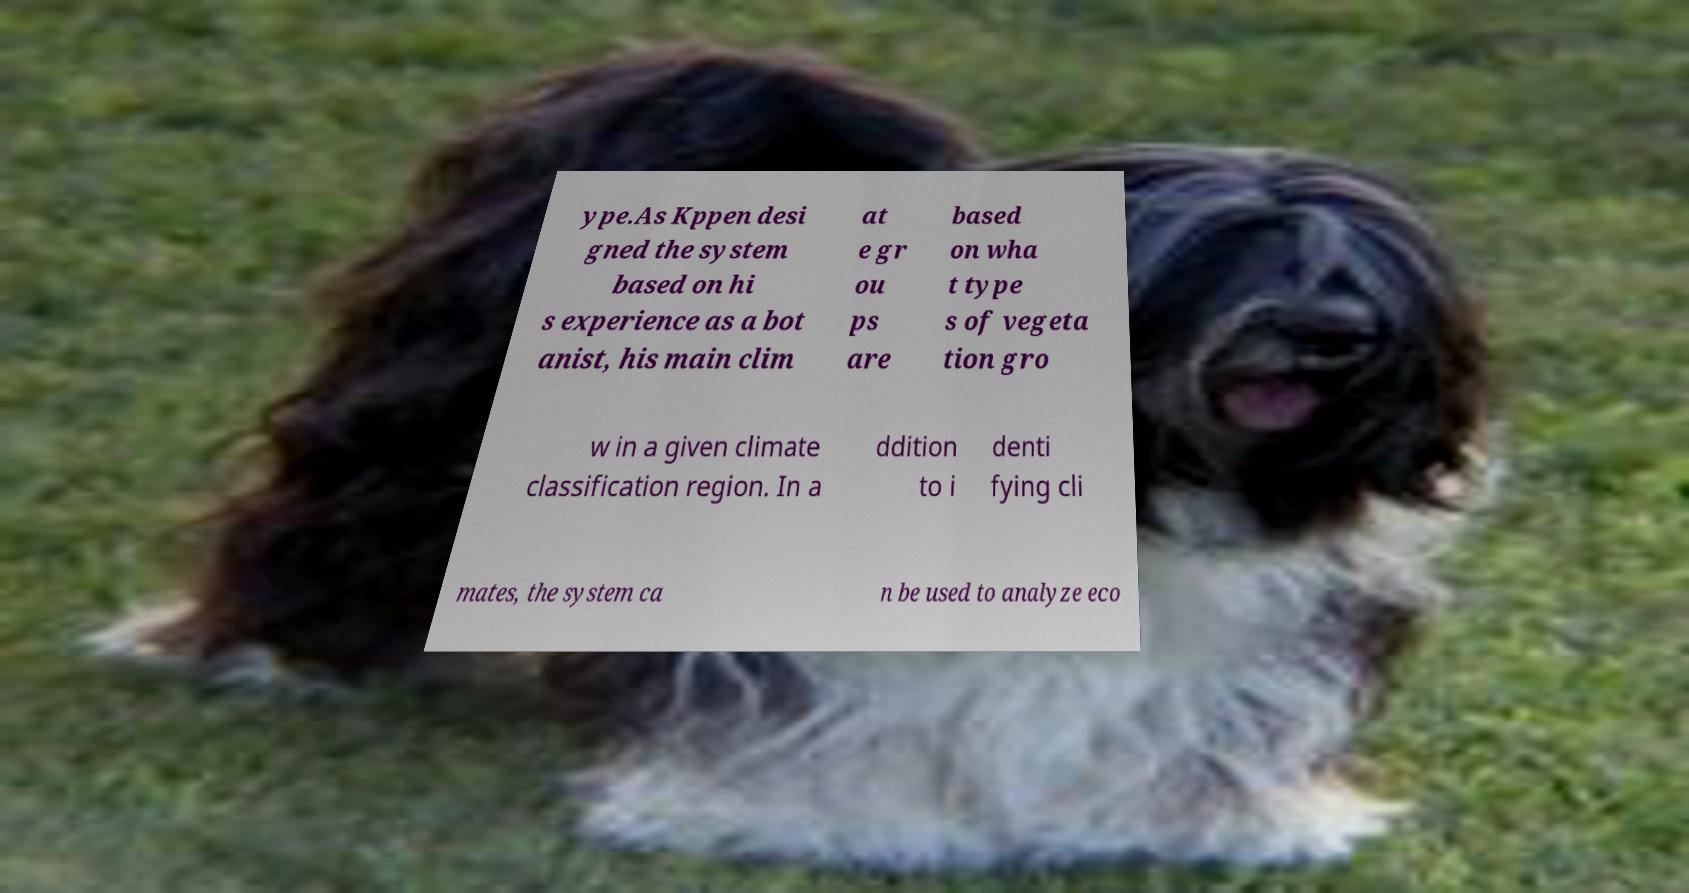There's text embedded in this image that I need extracted. Can you transcribe it verbatim? ype.As Kppen desi gned the system based on hi s experience as a bot anist, his main clim at e gr ou ps are based on wha t type s of vegeta tion gro w in a given climate classification region. In a ddition to i denti fying cli mates, the system ca n be used to analyze eco 